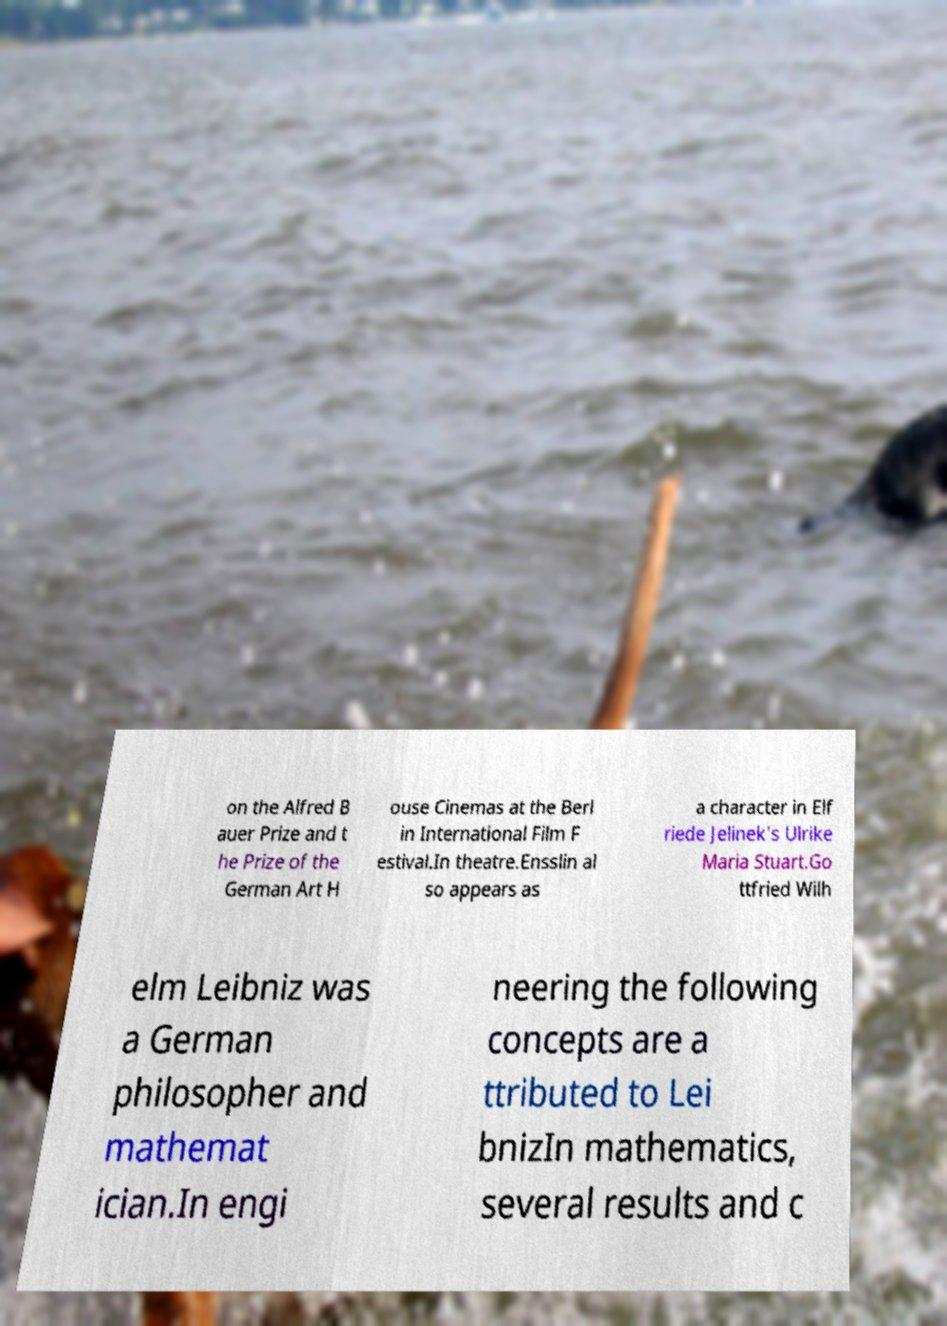For documentation purposes, I need the text within this image transcribed. Could you provide that? on the Alfred B auer Prize and t he Prize of the German Art H ouse Cinemas at the Berl in International Film F estival.In theatre.Ensslin al so appears as a character in Elf riede Jelinek's Ulrike Maria Stuart.Go ttfried Wilh elm Leibniz was a German philosopher and mathemat ician.In engi neering the following concepts are a ttributed to Lei bnizIn mathematics, several results and c 